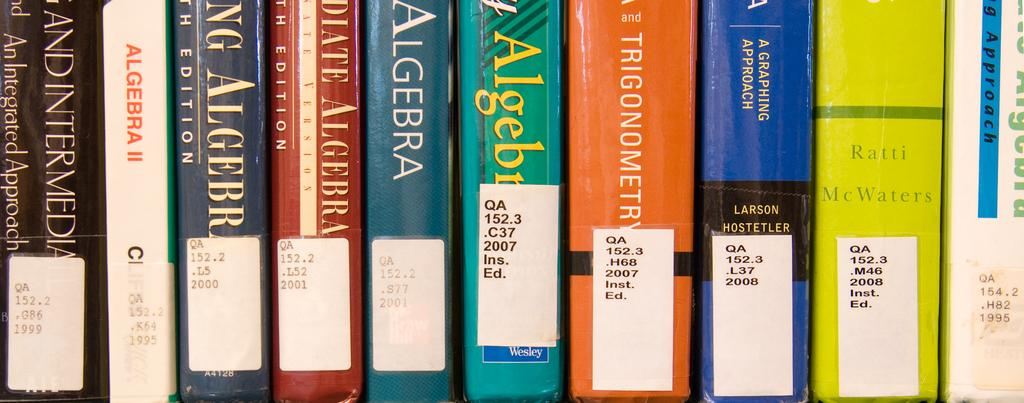Provide a one-sentence caption for the provided image. a libarary collection of books on Algebra. 